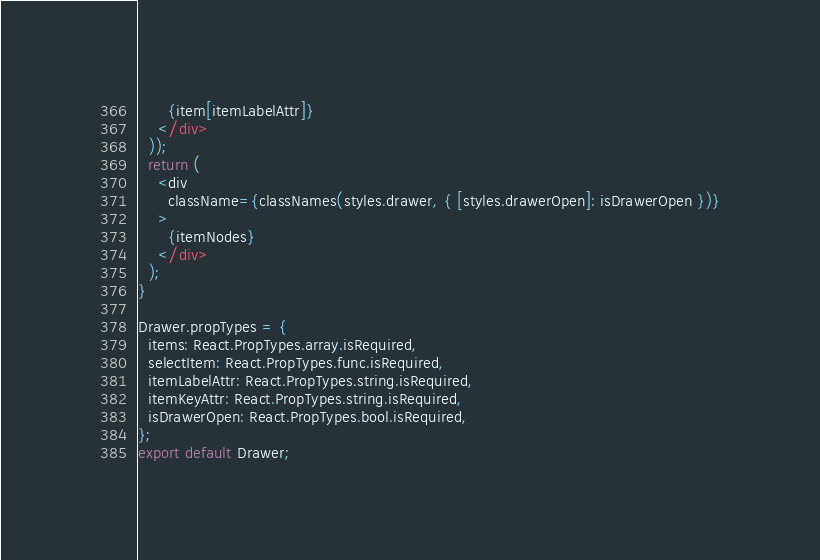Convert code to text. <code><loc_0><loc_0><loc_500><loc_500><_JavaScript_>      {item[itemLabelAttr]}
    </div>
  ));
  return (
    <div
      className={classNames(styles.drawer, { [styles.drawerOpen]: isDrawerOpen })}
    >
      {itemNodes}
    </div>
  );
}

Drawer.propTypes = {
  items: React.PropTypes.array.isRequired,
  selectItem: React.PropTypes.func.isRequired,
  itemLabelAttr: React.PropTypes.string.isRequired,
  itemKeyAttr: React.PropTypes.string.isRequired,
  isDrawerOpen: React.PropTypes.bool.isRequired,
};
export default Drawer;
</code> 